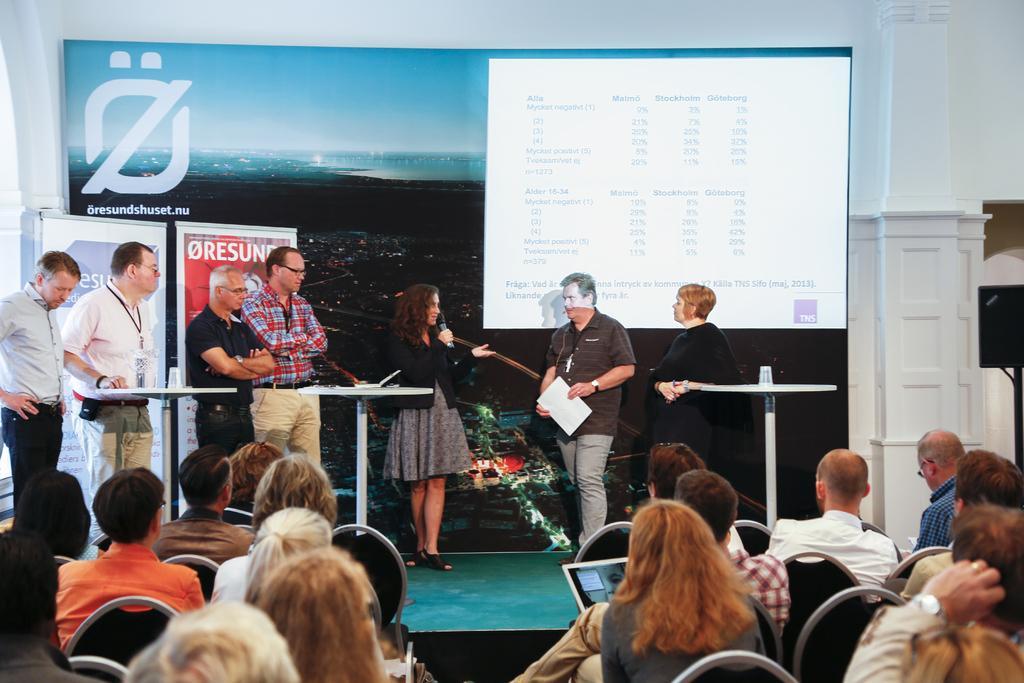Can you describe this image briefly? In the image we can see there are people who are standing on the stage and in front of them there are people who are sitting on chair and they are looking at them. 